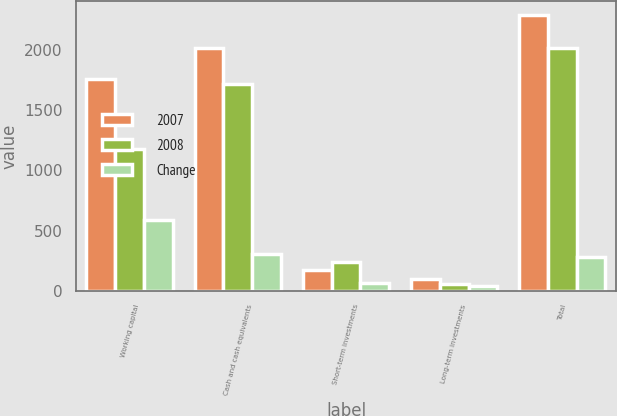Convert chart to OTSL. <chart><loc_0><loc_0><loc_500><loc_500><stacked_bar_chart><ecel><fcel>Working capital<fcel>Cash and cash equivalents<fcel>Short-term investments<fcel>Long-term investments<fcel>Total<nl><fcel>2007<fcel>1759.6<fcel>2019.1<fcel>172.9<fcel>101.4<fcel>2293.4<nl><fcel>2008<fcel>1175.3<fcel>1716.1<fcel>240.4<fcel>59.3<fcel>2015.8<nl><fcel>Change<fcel>584.3<fcel>303<fcel>67.5<fcel>42.1<fcel>277.6<nl></chart> 